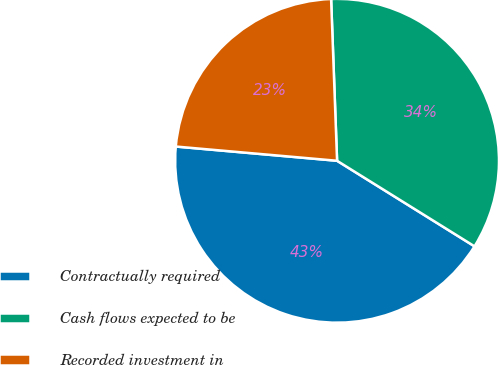Convert chart to OTSL. <chart><loc_0><loc_0><loc_500><loc_500><pie_chart><fcel>Contractually required<fcel>Cash flows expected to be<fcel>Recorded investment in<nl><fcel>42.54%<fcel>34.45%<fcel>23.01%<nl></chart> 